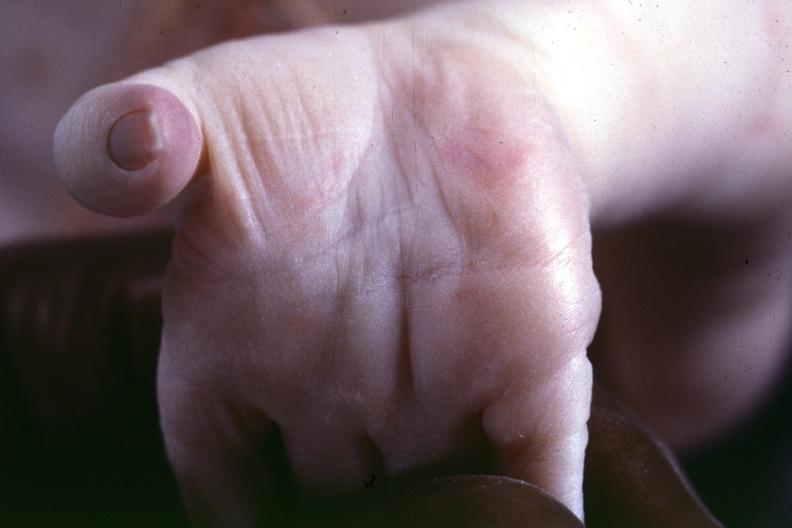what indicated?
Answer the question using a single word or phrase. Source 